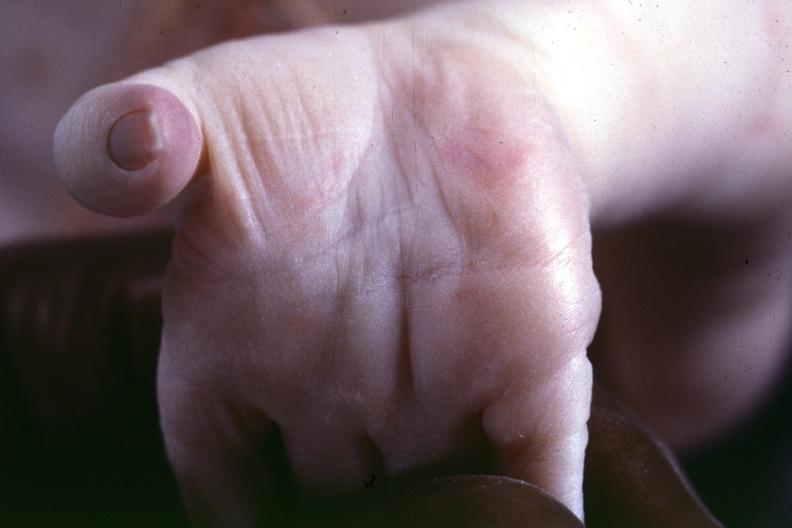what indicated?
Answer the question using a single word or phrase. Source 